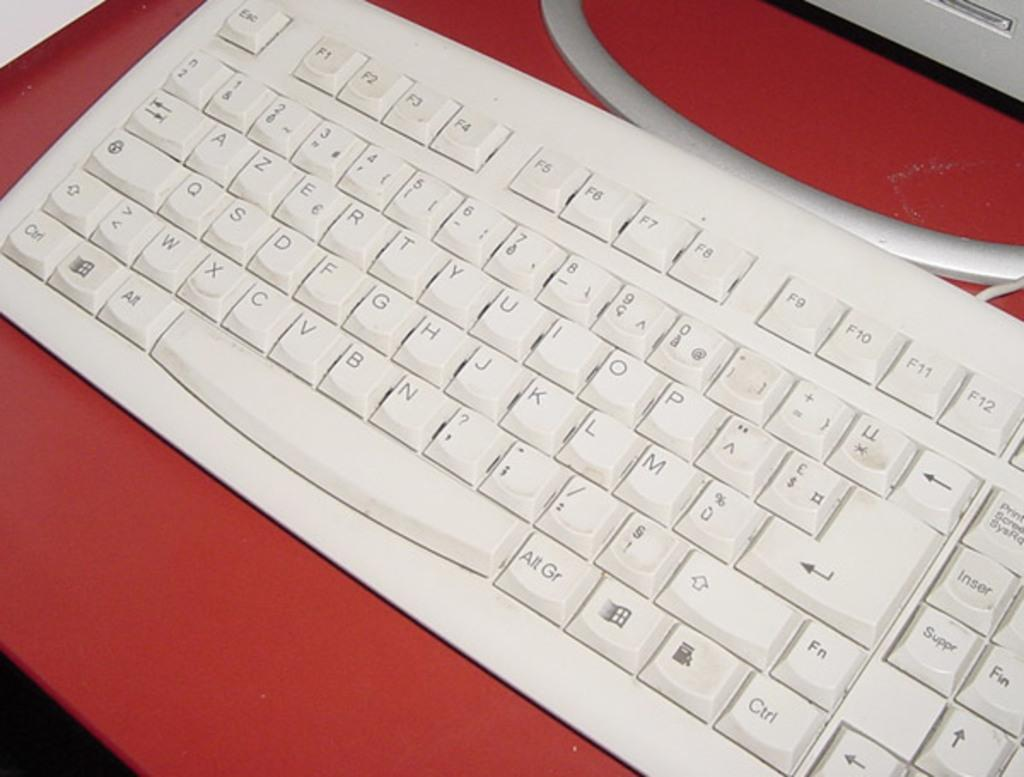<image>
Present a compact description of the photo's key features. A key that says Alt Gr is next to the space key on a white keyboard. 